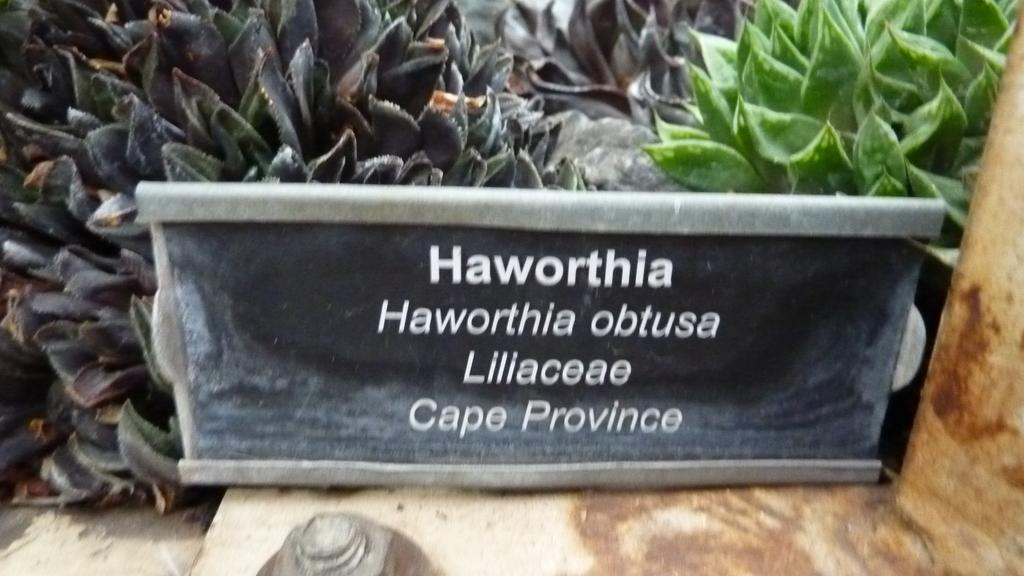What type of surface is at the bottom of the image? There is pavement at the bottom of the image. What is located in the middle of the image? There is a blackboard with text in the middle of the image. What can be seen in the background of the image? There are trees in the background of the image. What colors are the trees in the image? The trees are green and dark purple in color. What route is the market taking in the image? There is no market or route present in the image; it features a blackboard, trees, and pavement. How does the anger of the trees affect the text on the blackboard? There is no anger present in the image, and the trees do not have emotions. 